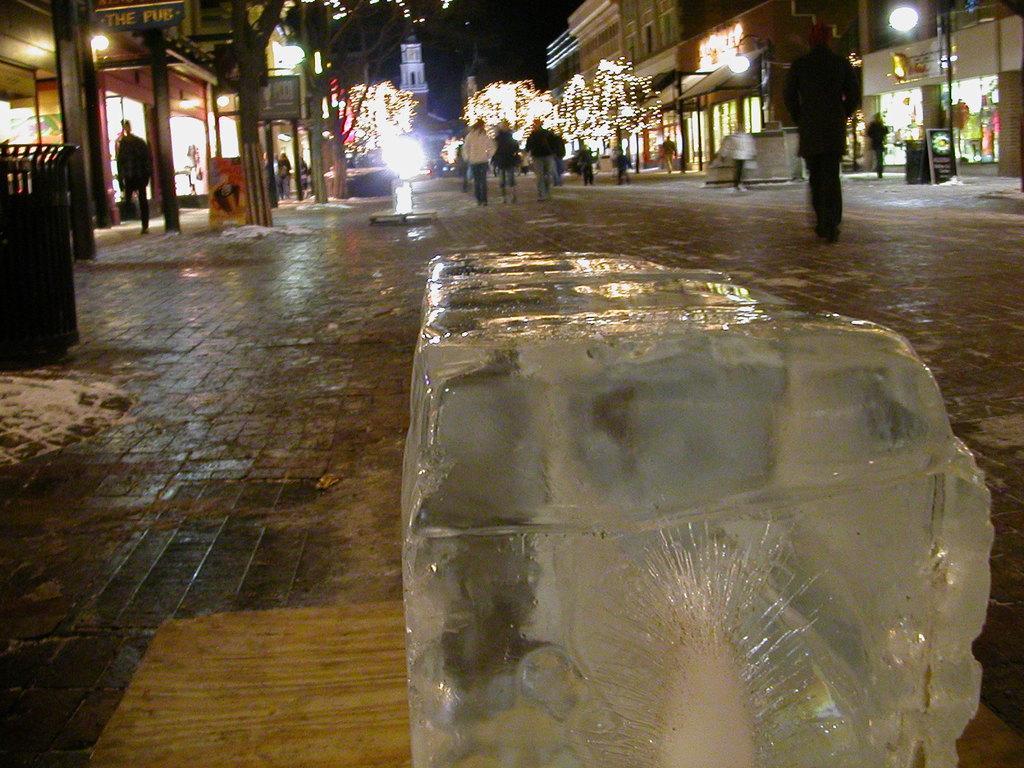Could you give a brief overview of what you see in this image? In this picture we can see an ice block in the front, there are some people in the background, we can see lights here, on the left side and right side there are buildings, we can see trees here, on the right side there is a hoarding. 